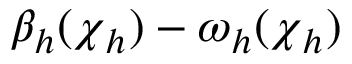Convert formula to latex. <formula><loc_0><loc_0><loc_500><loc_500>\beta _ { h } ( { \boldsymbol \chi } _ { h } ) - \omega _ { h } ( { \boldsymbol \chi } _ { h } )</formula> 